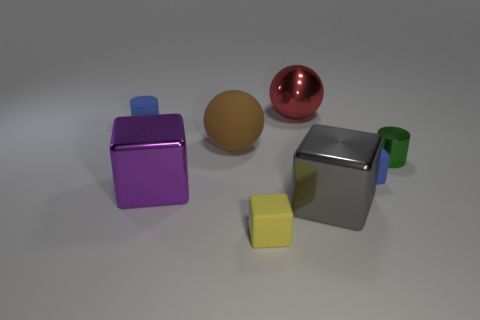Subtract all small blue matte cubes. How many cubes are left? 3 Add 1 green metal cylinders. How many objects exist? 9 Subtract all blue blocks. How many blocks are left? 3 Subtract 1 spheres. How many spheres are left? 1 Subtract all balls. How many objects are left? 6 Subtract all small gray rubber cubes. Subtract all small metal cylinders. How many objects are left? 7 Add 2 green things. How many green things are left? 3 Add 5 blue objects. How many blue objects exist? 7 Subtract 0 gray cylinders. How many objects are left? 8 Subtract all cyan cylinders. Subtract all brown cubes. How many cylinders are left? 2 